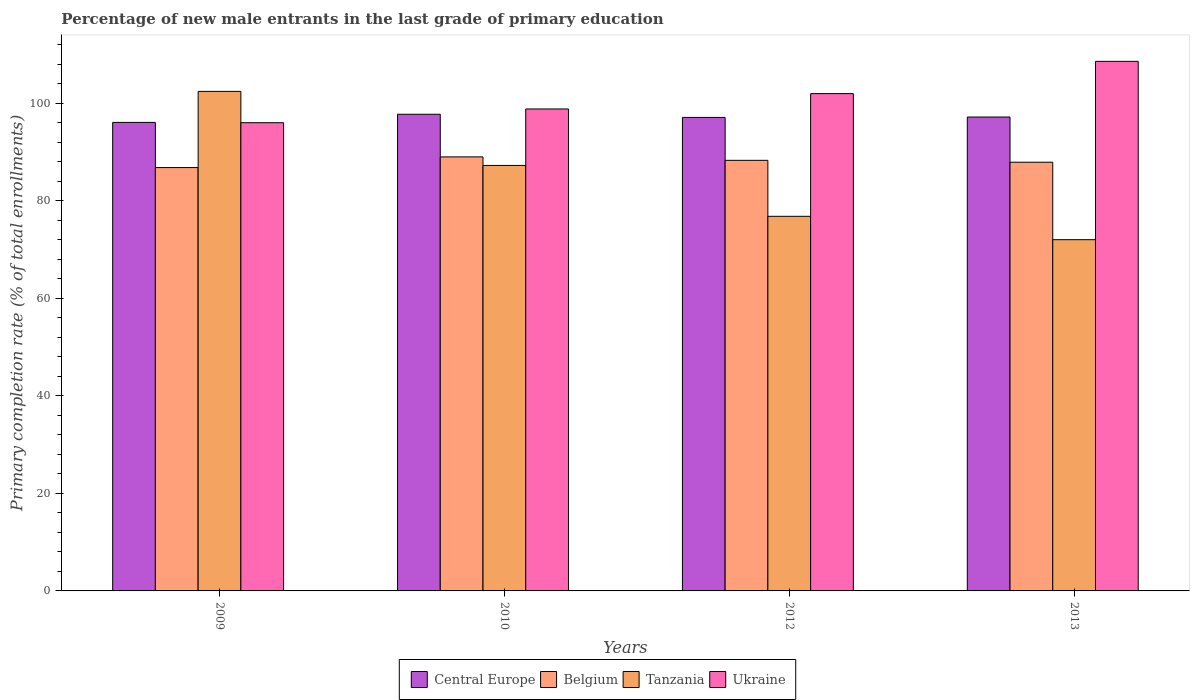How many different coloured bars are there?
Give a very brief answer. 4. Are the number of bars per tick equal to the number of legend labels?
Ensure brevity in your answer.  Yes. What is the percentage of new male entrants in Ukraine in 2013?
Provide a short and direct response. 108.61. Across all years, what is the maximum percentage of new male entrants in Tanzania?
Give a very brief answer. 102.45. Across all years, what is the minimum percentage of new male entrants in Tanzania?
Ensure brevity in your answer.  72.03. In which year was the percentage of new male entrants in Tanzania minimum?
Provide a short and direct response. 2013. What is the total percentage of new male entrants in Tanzania in the graph?
Your answer should be very brief. 338.57. What is the difference between the percentage of new male entrants in Tanzania in 2010 and that in 2013?
Provide a short and direct response. 15.23. What is the difference between the percentage of new male entrants in Tanzania in 2010 and the percentage of new male entrants in Central Europe in 2013?
Provide a succinct answer. -9.93. What is the average percentage of new male entrants in Ukraine per year?
Provide a short and direct response. 101.37. In the year 2010, what is the difference between the percentage of new male entrants in Ukraine and percentage of new male entrants in Central Europe?
Provide a succinct answer. 1.09. What is the ratio of the percentage of new male entrants in Belgium in 2010 to that in 2012?
Ensure brevity in your answer.  1.01. Is the difference between the percentage of new male entrants in Ukraine in 2010 and 2013 greater than the difference between the percentage of new male entrants in Central Europe in 2010 and 2013?
Make the answer very short. No. What is the difference between the highest and the second highest percentage of new male entrants in Tanzania?
Your response must be concise. 15.19. What is the difference between the highest and the lowest percentage of new male entrants in Tanzania?
Provide a succinct answer. 30.41. In how many years, is the percentage of new male entrants in Tanzania greater than the average percentage of new male entrants in Tanzania taken over all years?
Your answer should be very brief. 2. Is the sum of the percentage of new male entrants in Belgium in 2012 and 2013 greater than the maximum percentage of new male entrants in Central Europe across all years?
Ensure brevity in your answer.  Yes. What does the 4th bar from the left in 2012 represents?
Give a very brief answer. Ukraine. What does the 2nd bar from the right in 2009 represents?
Make the answer very short. Tanzania. Are all the bars in the graph horizontal?
Offer a very short reply. No. What is the difference between two consecutive major ticks on the Y-axis?
Provide a succinct answer. 20. Are the values on the major ticks of Y-axis written in scientific E-notation?
Provide a short and direct response. No. Does the graph contain any zero values?
Ensure brevity in your answer.  No. Does the graph contain grids?
Keep it short and to the point. No. What is the title of the graph?
Your answer should be very brief. Percentage of new male entrants in the last grade of primary education. What is the label or title of the X-axis?
Your answer should be very brief. Years. What is the label or title of the Y-axis?
Ensure brevity in your answer.  Primary completion rate (% of total enrollments). What is the Primary completion rate (% of total enrollments) in Central Europe in 2009?
Your answer should be compact. 96.09. What is the Primary completion rate (% of total enrollments) of Belgium in 2009?
Your response must be concise. 86.83. What is the Primary completion rate (% of total enrollments) of Tanzania in 2009?
Your response must be concise. 102.45. What is the Primary completion rate (% of total enrollments) in Ukraine in 2009?
Provide a short and direct response. 96.03. What is the Primary completion rate (% of total enrollments) in Central Europe in 2010?
Keep it short and to the point. 97.76. What is the Primary completion rate (% of total enrollments) in Belgium in 2010?
Offer a terse response. 89.01. What is the Primary completion rate (% of total enrollments) of Tanzania in 2010?
Offer a very short reply. 87.26. What is the Primary completion rate (% of total enrollments) in Ukraine in 2010?
Provide a succinct answer. 98.85. What is the Primary completion rate (% of total enrollments) of Central Europe in 2012?
Your answer should be compact. 97.11. What is the Primary completion rate (% of total enrollments) in Belgium in 2012?
Your answer should be very brief. 88.31. What is the Primary completion rate (% of total enrollments) of Tanzania in 2012?
Keep it short and to the point. 76.83. What is the Primary completion rate (% of total enrollments) of Ukraine in 2012?
Provide a succinct answer. 102. What is the Primary completion rate (% of total enrollments) in Central Europe in 2013?
Keep it short and to the point. 97.19. What is the Primary completion rate (% of total enrollments) in Belgium in 2013?
Your response must be concise. 87.92. What is the Primary completion rate (% of total enrollments) in Tanzania in 2013?
Your answer should be very brief. 72.03. What is the Primary completion rate (% of total enrollments) of Ukraine in 2013?
Your answer should be very brief. 108.61. Across all years, what is the maximum Primary completion rate (% of total enrollments) in Central Europe?
Provide a short and direct response. 97.76. Across all years, what is the maximum Primary completion rate (% of total enrollments) in Belgium?
Ensure brevity in your answer.  89.01. Across all years, what is the maximum Primary completion rate (% of total enrollments) in Tanzania?
Your answer should be very brief. 102.45. Across all years, what is the maximum Primary completion rate (% of total enrollments) in Ukraine?
Ensure brevity in your answer.  108.61. Across all years, what is the minimum Primary completion rate (% of total enrollments) of Central Europe?
Your response must be concise. 96.09. Across all years, what is the minimum Primary completion rate (% of total enrollments) in Belgium?
Your answer should be compact. 86.83. Across all years, what is the minimum Primary completion rate (% of total enrollments) of Tanzania?
Ensure brevity in your answer.  72.03. Across all years, what is the minimum Primary completion rate (% of total enrollments) in Ukraine?
Ensure brevity in your answer.  96.03. What is the total Primary completion rate (% of total enrollments) of Central Europe in the graph?
Provide a succinct answer. 388.15. What is the total Primary completion rate (% of total enrollments) in Belgium in the graph?
Your response must be concise. 352.07. What is the total Primary completion rate (% of total enrollments) in Tanzania in the graph?
Your answer should be compact. 338.57. What is the total Primary completion rate (% of total enrollments) of Ukraine in the graph?
Provide a short and direct response. 405.48. What is the difference between the Primary completion rate (% of total enrollments) in Central Europe in 2009 and that in 2010?
Give a very brief answer. -1.67. What is the difference between the Primary completion rate (% of total enrollments) in Belgium in 2009 and that in 2010?
Your answer should be compact. -2.19. What is the difference between the Primary completion rate (% of total enrollments) of Tanzania in 2009 and that in 2010?
Provide a succinct answer. 15.19. What is the difference between the Primary completion rate (% of total enrollments) of Ukraine in 2009 and that in 2010?
Your answer should be compact. -2.82. What is the difference between the Primary completion rate (% of total enrollments) of Central Europe in 2009 and that in 2012?
Ensure brevity in your answer.  -1.02. What is the difference between the Primary completion rate (% of total enrollments) in Belgium in 2009 and that in 2012?
Provide a succinct answer. -1.48. What is the difference between the Primary completion rate (% of total enrollments) in Tanzania in 2009 and that in 2012?
Give a very brief answer. 25.62. What is the difference between the Primary completion rate (% of total enrollments) in Ukraine in 2009 and that in 2012?
Keep it short and to the point. -5.97. What is the difference between the Primary completion rate (% of total enrollments) in Central Europe in 2009 and that in 2013?
Your response must be concise. -1.1. What is the difference between the Primary completion rate (% of total enrollments) in Belgium in 2009 and that in 2013?
Make the answer very short. -1.1. What is the difference between the Primary completion rate (% of total enrollments) of Tanzania in 2009 and that in 2013?
Your answer should be compact. 30.41. What is the difference between the Primary completion rate (% of total enrollments) of Ukraine in 2009 and that in 2013?
Give a very brief answer. -12.58. What is the difference between the Primary completion rate (% of total enrollments) in Central Europe in 2010 and that in 2012?
Provide a succinct answer. 0.65. What is the difference between the Primary completion rate (% of total enrollments) in Belgium in 2010 and that in 2012?
Ensure brevity in your answer.  0.7. What is the difference between the Primary completion rate (% of total enrollments) of Tanzania in 2010 and that in 2012?
Your answer should be compact. 10.43. What is the difference between the Primary completion rate (% of total enrollments) in Ukraine in 2010 and that in 2012?
Keep it short and to the point. -3.15. What is the difference between the Primary completion rate (% of total enrollments) of Central Europe in 2010 and that in 2013?
Give a very brief answer. 0.56. What is the difference between the Primary completion rate (% of total enrollments) of Tanzania in 2010 and that in 2013?
Offer a terse response. 15.23. What is the difference between the Primary completion rate (% of total enrollments) in Ukraine in 2010 and that in 2013?
Offer a terse response. -9.76. What is the difference between the Primary completion rate (% of total enrollments) in Central Europe in 2012 and that in 2013?
Your response must be concise. -0.08. What is the difference between the Primary completion rate (% of total enrollments) in Belgium in 2012 and that in 2013?
Keep it short and to the point. 0.39. What is the difference between the Primary completion rate (% of total enrollments) of Tanzania in 2012 and that in 2013?
Give a very brief answer. 4.79. What is the difference between the Primary completion rate (% of total enrollments) of Ukraine in 2012 and that in 2013?
Ensure brevity in your answer.  -6.61. What is the difference between the Primary completion rate (% of total enrollments) of Central Europe in 2009 and the Primary completion rate (% of total enrollments) of Belgium in 2010?
Your answer should be very brief. 7.08. What is the difference between the Primary completion rate (% of total enrollments) in Central Europe in 2009 and the Primary completion rate (% of total enrollments) in Tanzania in 2010?
Provide a succinct answer. 8.83. What is the difference between the Primary completion rate (% of total enrollments) in Central Europe in 2009 and the Primary completion rate (% of total enrollments) in Ukraine in 2010?
Make the answer very short. -2.76. What is the difference between the Primary completion rate (% of total enrollments) of Belgium in 2009 and the Primary completion rate (% of total enrollments) of Tanzania in 2010?
Provide a short and direct response. -0.44. What is the difference between the Primary completion rate (% of total enrollments) in Belgium in 2009 and the Primary completion rate (% of total enrollments) in Ukraine in 2010?
Offer a very short reply. -12.02. What is the difference between the Primary completion rate (% of total enrollments) of Tanzania in 2009 and the Primary completion rate (% of total enrollments) of Ukraine in 2010?
Provide a short and direct response. 3.6. What is the difference between the Primary completion rate (% of total enrollments) in Central Europe in 2009 and the Primary completion rate (% of total enrollments) in Belgium in 2012?
Provide a succinct answer. 7.78. What is the difference between the Primary completion rate (% of total enrollments) of Central Europe in 2009 and the Primary completion rate (% of total enrollments) of Tanzania in 2012?
Your answer should be compact. 19.26. What is the difference between the Primary completion rate (% of total enrollments) in Central Europe in 2009 and the Primary completion rate (% of total enrollments) in Ukraine in 2012?
Your answer should be very brief. -5.91. What is the difference between the Primary completion rate (% of total enrollments) in Belgium in 2009 and the Primary completion rate (% of total enrollments) in Tanzania in 2012?
Provide a short and direct response. 10. What is the difference between the Primary completion rate (% of total enrollments) of Belgium in 2009 and the Primary completion rate (% of total enrollments) of Ukraine in 2012?
Provide a short and direct response. -15.17. What is the difference between the Primary completion rate (% of total enrollments) of Tanzania in 2009 and the Primary completion rate (% of total enrollments) of Ukraine in 2012?
Provide a succinct answer. 0.45. What is the difference between the Primary completion rate (% of total enrollments) in Central Europe in 2009 and the Primary completion rate (% of total enrollments) in Belgium in 2013?
Your answer should be compact. 8.17. What is the difference between the Primary completion rate (% of total enrollments) of Central Europe in 2009 and the Primary completion rate (% of total enrollments) of Tanzania in 2013?
Your answer should be very brief. 24.05. What is the difference between the Primary completion rate (% of total enrollments) in Central Europe in 2009 and the Primary completion rate (% of total enrollments) in Ukraine in 2013?
Give a very brief answer. -12.52. What is the difference between the Primary completion rate (% of total enrollments) of Belgium in 2009 and the Primary completion rate (% of total enrollments) of Tanzania in 2013?
Ensure brevity in your answer.  14.79. What is the difference between the Primary completion rate (% of total enrollments) of Belgium in 2009 and the Primary completion rate (% of total enrollments) of Ukraine in 2013?
Offer a very short reply. -21.78. What is the difference between the Primary completion rate (% of total enrollments) of Tanzania in 2009 and the Primary completion rate (% of total enrollments) of Ukraine in 2013?
Keep it short and to the point. -6.16. What is the difference between the Primary completion rate (% of total enrollments) of Central Europe in 2010 and the Primary completion rate (% of total enrollments) of Belgium in 2012?
Your answer should be compact. 9.45. What is the difference between the Primary completion rate (% of total enrollments) of Central Europe in 2010 and the Primary completion rate (% of total enrollments) of Tanzania in 2012?
Your answer should be very brief. 20.93. What is the difference between the Primary completion rate (% of total enrollments) of Central Europe in 2010 and the Primary completion rate (% of total enrollments) of Ukraine in 2012?
Ensure brevity in your answer.  -4.24. What is the difference between the Primary completion rate (% of total enrollments) of Belgium in 2010 and the Primary completion rate (% of total enrollments) of Tanzania in 2012?
Provide a short and direct response. 12.19. What is the difference between the Primary completion rate (% of total enrollments) of Belgium in 2010 and the Primary completion rate (% of total enrollments) of Ukraine in 2012?
Give a very brief answer. -12.98. What is the difference between the Primary completion rate (% of total enrollments) of Tanzania in 2010 and the Primary completion rate (% of total enrollments) of Ukraine in 2012?
Give a very brief answer. -14.74. What is the difference between the Primary completion rate (% of total enrollments) in Central Europe in 2010 and the Primary completion rate (% of total enrollments) in Belgium in 2013?
Keep it short and to the point. 9.84. What is the difference between the Primary completion rate (% of total enrollments) in Central Europe in 2010 and the Primary completion rate (% of total enrollments) in Tanzania in 2013?
Provide a short and direct response. 25.72. What is the difference between the Primary completion rate (% of total enrollments) in Central Europe in 2010 and the Primary completion rate (% of total enrollments) in Ukraine in 2013?
Provide a succinct answer. -10.85. What is the difference between the Primary completion rate (% of total enrollments) of Belgium in 2010 and the Primary completion rate (% of total enrollments) of Tanzania in 2013?
Your answer should be compact. 16.98. What is the difference between the Primary completion rate (% of total enrollments) in Belgium in 2010 and the Primary completion rate (% of total enrollments) in Ukraine in 2013?
Give a very brief answer. -19.6. What is the difference between the Primary completion rate (% of total enrollments) in Tanzania in 2010 and the Primary completion rate (% of total enrollments) in Ukraine in 2013?
Offer a terse response. -21.35. What is the difference between the Primary completion rate (% of total enrollments) in Central Europe in 2012 and the Primary completion rate (% of total enrollments) in Belgium in 2013?
Offer a terse response. 9.19. What is the difference between the Primary completion rate (% of total enrollments) in Central Europe in 2012 and the Primary completion rate (% of total enrollments) in Tanzania in 2013?
Your response must be concise. 25.07. What is the difference between the Primary completion rate (% of total enrollments) of Central Europe in 2012 and the Primary completion rate (% of total enrollments) of Ukraine in 2013?
Make the answer very short. -11.5. What is the difference between the Primary completion rate (% of total enrollments) of Belgium in 2012 and the Primary completion rate (% of total enrollments) of Tanzania in 2013?
Your response must be concise. 16.28. What is the difference between the Primary completion rate (% of total enrollments) in Belgium in 2012 and the Primary completion rate (% of total enrollments) in Ukraine in 2013?
Your answer should be compact. -20.3. What is the difference between the Primary completion rate (% of total enrollments) of Tanzania in 2012 and the Primary completion rate (% of total enrollments) of Ukraine in 2013?
Provide a short and direct response. -31.78. What is the average Primary completion rate (% of total enrollments) in Central Europe per year?
Provide a short and direct response. 97.04. What is the average Primary completion rate (% of total enrollments) of Belgium per year?
Offer a terse response. 88.02. What is the average Primary completion rate (% of total enrollments) in Tanzania per year?
Provide a succinct answer. 84.64. What is the average Primary completion rate (% of total enrollments) of Ukraine per year?
Your answer should be compact. 101.37. In the year 2009, what is the difference between the Primary completion rate (% of total enrollments) of Central Europe and Primary completion rate (% of total enrollments) of Belgium?
Make the answer very short. 9.26. In the year 2009, what is the difference between the Primary completion rate (% of total enrollments) of Central Europe and Primary completion rate (% of total enrollments) of Tanzania?
Make the answer very short. -6.36. In the year 2009, what is the difference between the Primary completion rate (% of total enrollments) in Central Europe and Primary completion rate (% of total enrollments) in Ukraine?
Your answer should be compact. 0.06. In the year 2009, what is the difference between the Primary completion rate (% of total enrollments) of Belgium and Primary completion rate (% of total enrollments) of Tanzania?
Your answer should be very brief. -15.62. In the year 2009, what is the difference between the Primary completion rate (% of total enrollments) in Belgium and Primary completion rate (% of total enrollments) in Ukraine?
Keep it short and to the point. -9.2. In the year 2009, what is the difference between the Primary completion rate (% of total enrollments) of Tanzania and Primary completion rate (% of total enrollments) of Ukraine?
Keep it short and to the point. 6.42. In the year 2010, what is the difference between the Primary completion rate (% of total enrollments) in Central Europe and Primary completion rate (% of total enrollments) in Belgium?
Offer a terse response. 8.74. In the year 2010, what is the difference between the Primary completion rate (% of total enrollments) in Central Europe and Primary completion rate (% of total enrollments) in Tanzania?
Give a very brief answer. 10.5. In the year 2010, what is the difference between the Primary completion rate (% of total enrollments) of Central Europe and Primary completion rate (% of total enrollments) of Ukraine?
Your answer should be compact. -1.09. In the year 2010, what is the difference between the Primary completion rate (% of total enrollments) in Belgium and Primary completion rate (% of total enrollments) in Tanzania?
Offer a terse response. 1.75. In the year 2010, what is the difference between the Primary completion rate (% of total enrollments) in Belgium and Primary completion rate (% of total enrollments) in Ukraine?
Give a very brief answer. -9.83. In the year 2010, what is the difference between the Primary completion rate (% of total enrollments) of Tanzania and Primary completion rate (% of total enrollments) of Ukraine?
Offer a terse response. -11.58. In the year 2012, what is the difference between the Primary completion rate (% of total enrollments) in Central Europe and Primary completion rate (% of total enrollments) in Belgium?
Make the answer very short. 8.8. In the year 2012, what is the difference between the Primary completion rate (% of total enrollments) of Central Europe and Primary completion rate (% of total enrollments) of Tanzania?
Provide a short and direct response. 20.28. In the year 2012, what is the difference between the Primary completion rate (% of total enrollments) in Central Europe and Primary completion rate (% of total enrollments) in Ukraine?
Your answer should be compact. -4.89. In the year 2012, what is the difference between the Primary completion rate (% of total enrollments) in Belgium and Primary completion rate (% of total enrollments) in Tanzania?
Your response must be concise. 11.48. In the year 2012, what is the difference between the Primary completion rate (% of total enrollments) in Belgium and Primary completion rate (% of total enrollments) in Ukraine?
Keep it short and to the point. -13.69. In the year 2012, what is the difference between the Primary completion rate (% of total enrollments) of Tanzania and Primary completion rate (% of total enrollments) of Ukraine?
Provide a short and direct response. -25.17. In the year 2013, what is the difference between the Primary completion rate (% of total enrollments) of Central Europe and Primary completion rate (% of total enrollments) of Belgium?
Offer a very short reply. 9.27. In the year 2013, what is the difference between the Primary completion rate (% of total enrollments) in Central Europe and Primary completion rate (% of total enrollments) in Tanzania?
Make the answer very short. 25.16. In the year 2013, what is the difference between the Primary completion rate (% of total enrollments) in Central Europe and Primary completion rate (% of total enrollments) in Ukraine?
Make the answer very short. -11.42. In the year 2013, what is the difference between the Primary completion rate (% of total enrollments) of Belgium and Primary completion rate (% of total enrollments) of Tanzania?
Your response must be concise. 15.89. In the year 2013, what is the difference between the Primary completion rate (% of total enrollments) of Belgium and Primary completion rate (% of total enrollments) of Ukraine?
Ensure brevity in your answer.  -20.69. In the year 2013, what is the difference between the Primary completion rate (% of total enrollments) of Tanzania and Primary completion rate (% of total enrollments) of Ukraine?
Your response must be concise. -36.57. What is the ratio of the Primary completion rate (% of total enrollments) in Central Europe in 2009 to that in 2010?
Ensure brevity in your answer.  0.98. What is the ratio of the Primary completion rate (% of total enrollments) in Belgium in 2009 to that in 2010?
Give a very brief answer. 0.98. What is the ratio of the Primary completion rate (% of total enrollments) of Tanzania in 2009 to that in 2010?
Provide a short and direct response. 1.17. What is the ratio of the Primary completion rate (% of total enrollments) in Ukraine in 2009 to that in 2010?
Make the answer very short. 0.97. What is the ratio of the Primary completion rate (% of total enrollments) of Central Europe in 2009 to that in 2012?
Your response must be concise. 0.99. What is the ratio of the Primary completion rate (% of total enrollments) in Belgium in 2009 to that in 2012?
Your answer should be compact. 0.98. What is the ratio of the Primary completion rate (% of total enrollments) in Tanzania in 2009 to that in 2012?
Your response must be concise. 1.33. What is the ratio of the Primary completion rate (% of total enrollments) of Ukraine in 2009 to that in 2012?
Provide a short and direct response. 0.94. What is the ratio of the Primary completion rate (% of total enrollments) in Belgium in 2009 to that in 2013?
Make the answer very short. 0.99. What is the ratio of the Primary completion rate (% of total enrollments) of Tanzania in 2009 to that in 2013?
Offer a very short reply. 1.42. What is the ratio of the Primary completion rate (% of total enrollments) of Ukraine in 2009 to that in 2013?
Ensure brevity in your answer.  0.88. What is the ratio of the Primary completion rate (% of total enrollments) in Central Europe in 2010 to that in 2012?
Ensure brevity in your answer.  1.01. What is the ratio of the Primary completion rate (% of total enrollments) in Tanzania in 2010 to that in 2012?
Offer a terse response. 1.14. What is the ratio of the Primary completion rate (% of total enrollments) of Ukraine in 2010 to that in 2012?
Your answer should be compact. 0.97. What is the ratio of the Primary completion rate (% of total enrollments) of Belgium in 2010 to that in 2013?
Your answer should be very brief. 1.01. What is the ratio of the Primary completion rate (% of total enrollments) in Tanzania in 2010 to that in 2013?
Your answer should be compact. 1.21. What is the ratio of the Primary completion rate (% of total enrollments) in Ukraine in 2010 to that in 2013?
Keep it short and to the point. 0.91. What is the ratio of the Primary completion rate (% of total enrollments) in Central Europe in 2012 to that in 2013?
Your answer should be very brief. 1. What is the ratio of the Primary completion rate (% of total enrollments) of Tanzania in 2012 to that in 2013?
Keep it short and to the point. 1.07. What is the ratio of the Primary completion rate (% of total enrollments) of Ukraine in 2012 to that in 2013?
Make the answer very short. 0.94. What is the difference between the highest and the second highest Primary completion rate (% of total enrollments) of Central Europe?
Make the answer very short. 0.56. What is the difference between the highest and the second highest Primary completion rate (% of total enrollments) in Belgium?
Offer a terse response. 0.7. What is the difference between the highest and the second highest Primary completion rate (% of total enrollments) in Tanzania?
Provide a succinct answer. 15.19. What is the difference between the highest and the second highest Primary completion rate (% of total enrollments) of Ukraine?
Offer a very short reply. 6.61. What is the difference between the highest and the lowest Primary completion rate (% of total enrollments) of Central Europe?
Offer a very short reply. 1.67. What is the difference between the highest and the lowest Primary completion rate (% of total enrollments) of Belgium?
Ensure brevity in your answer.  2.19. What is the difference between the highest and the lowest Primary completion rate (% of total enrollments) of Tanzania?
Your answer should be compact. 30.41. What is the difference between the highest and the lowest Primary completion rate (% of total enrollments) in Ukraine?
Your answer should be very brief. 12.58. 